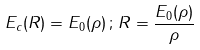<formula> <loc_0><loc_0><loc_500><loc_500>E _ { c } ( R ) = E _ { 0 } ( \rho ) \, ; \, R = \frac { E _ { 0 } ( \rho ) } { \rho }</formula> 